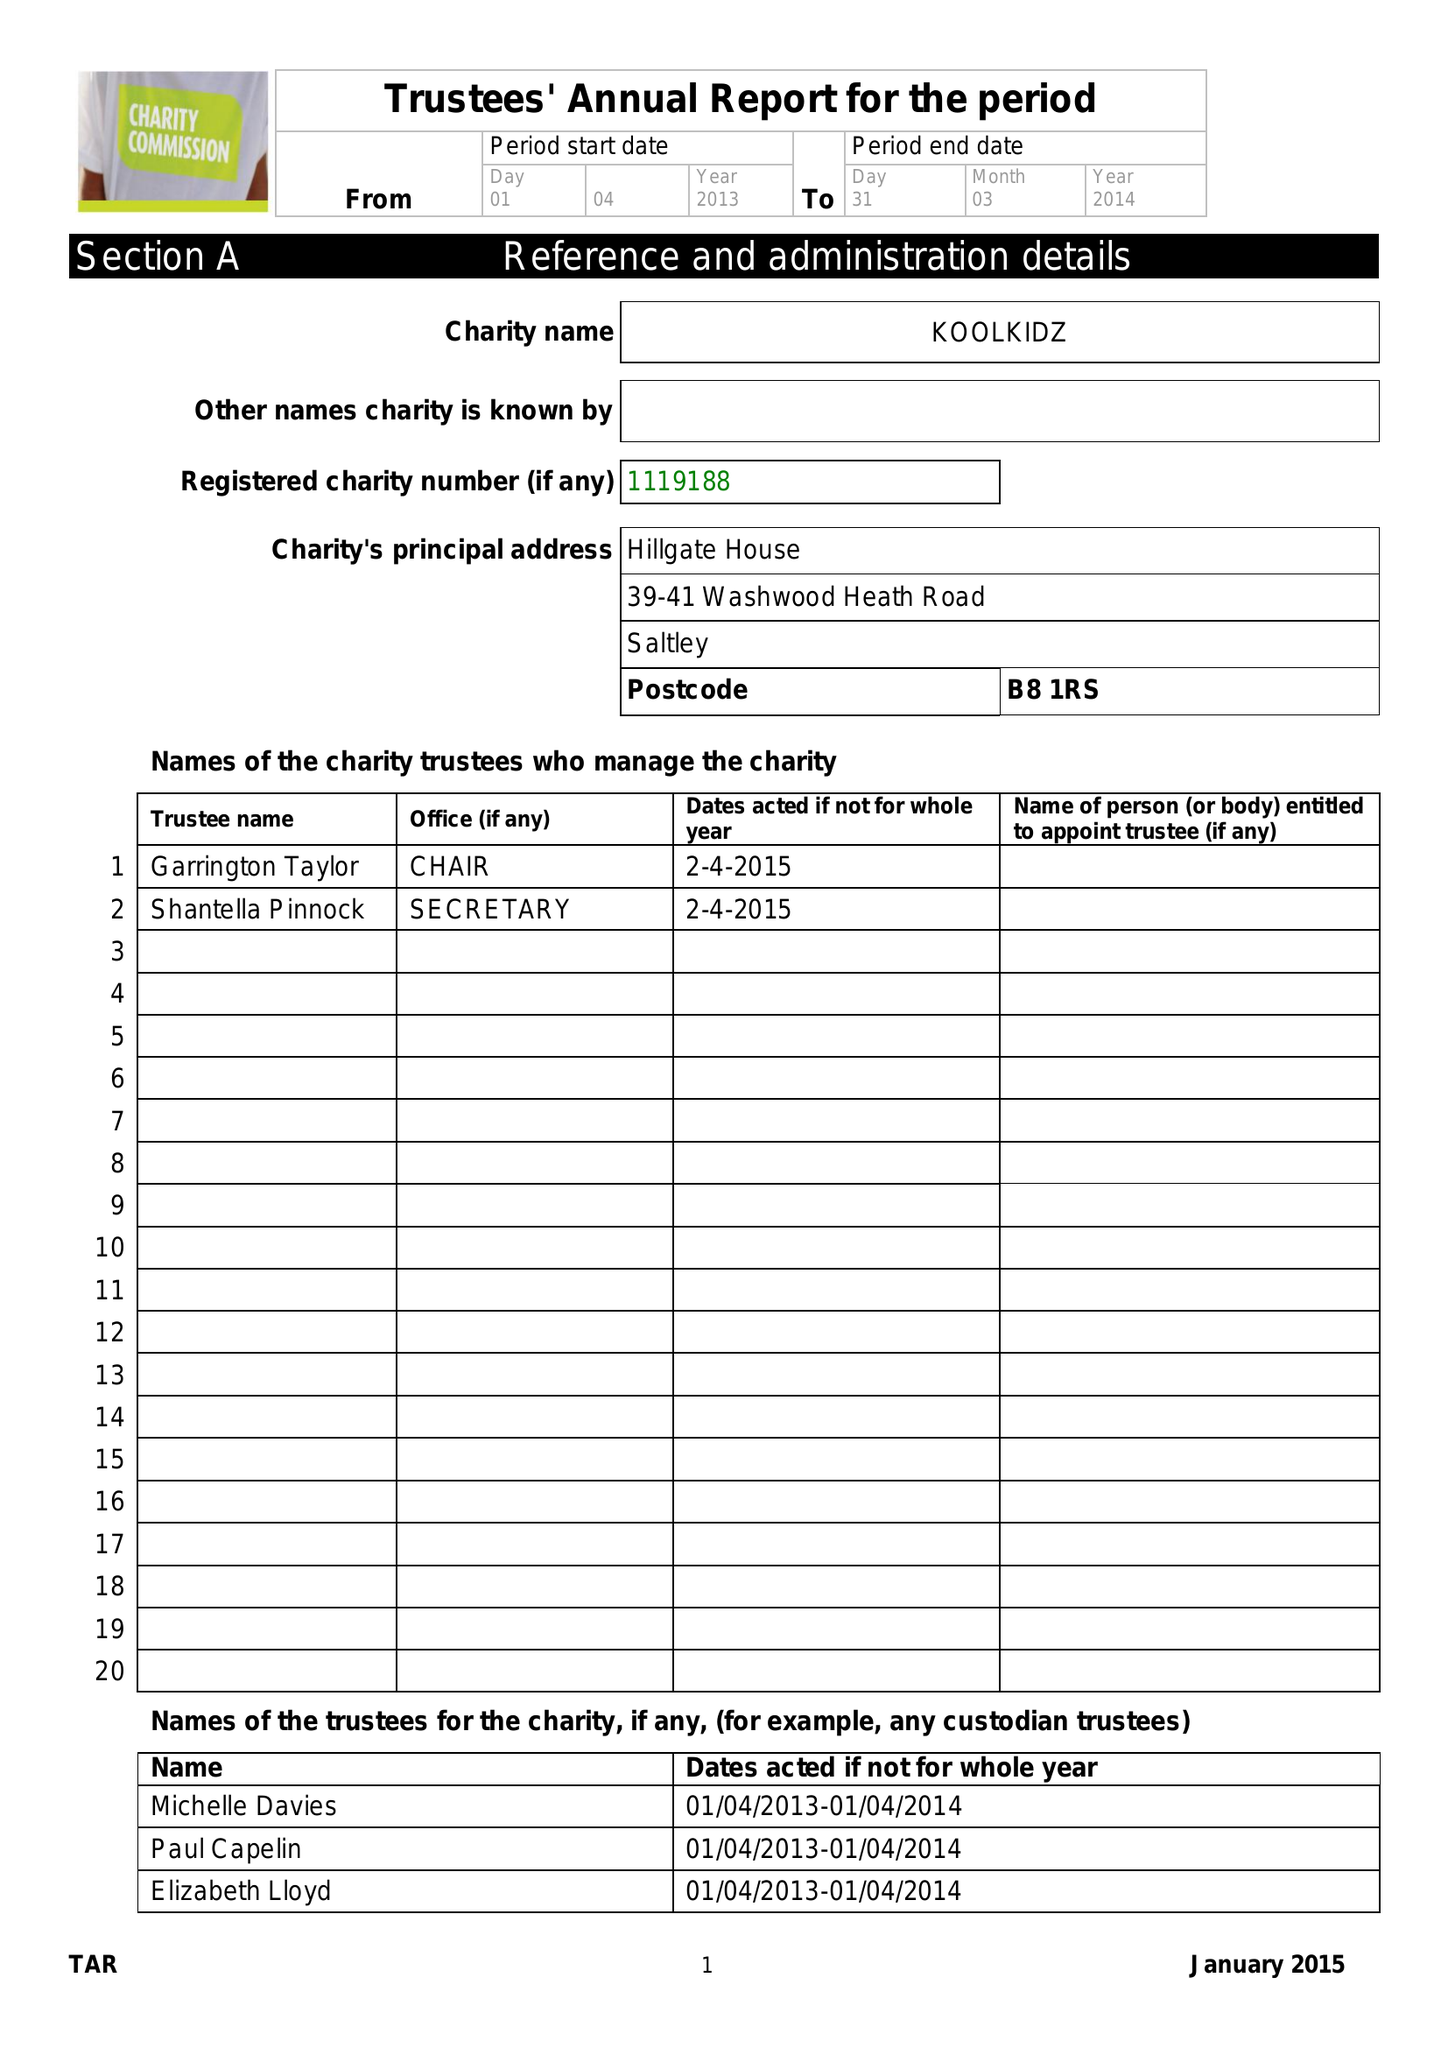What is the value for the charity_number?
Answer the question using a single word or phrase. 1119188 